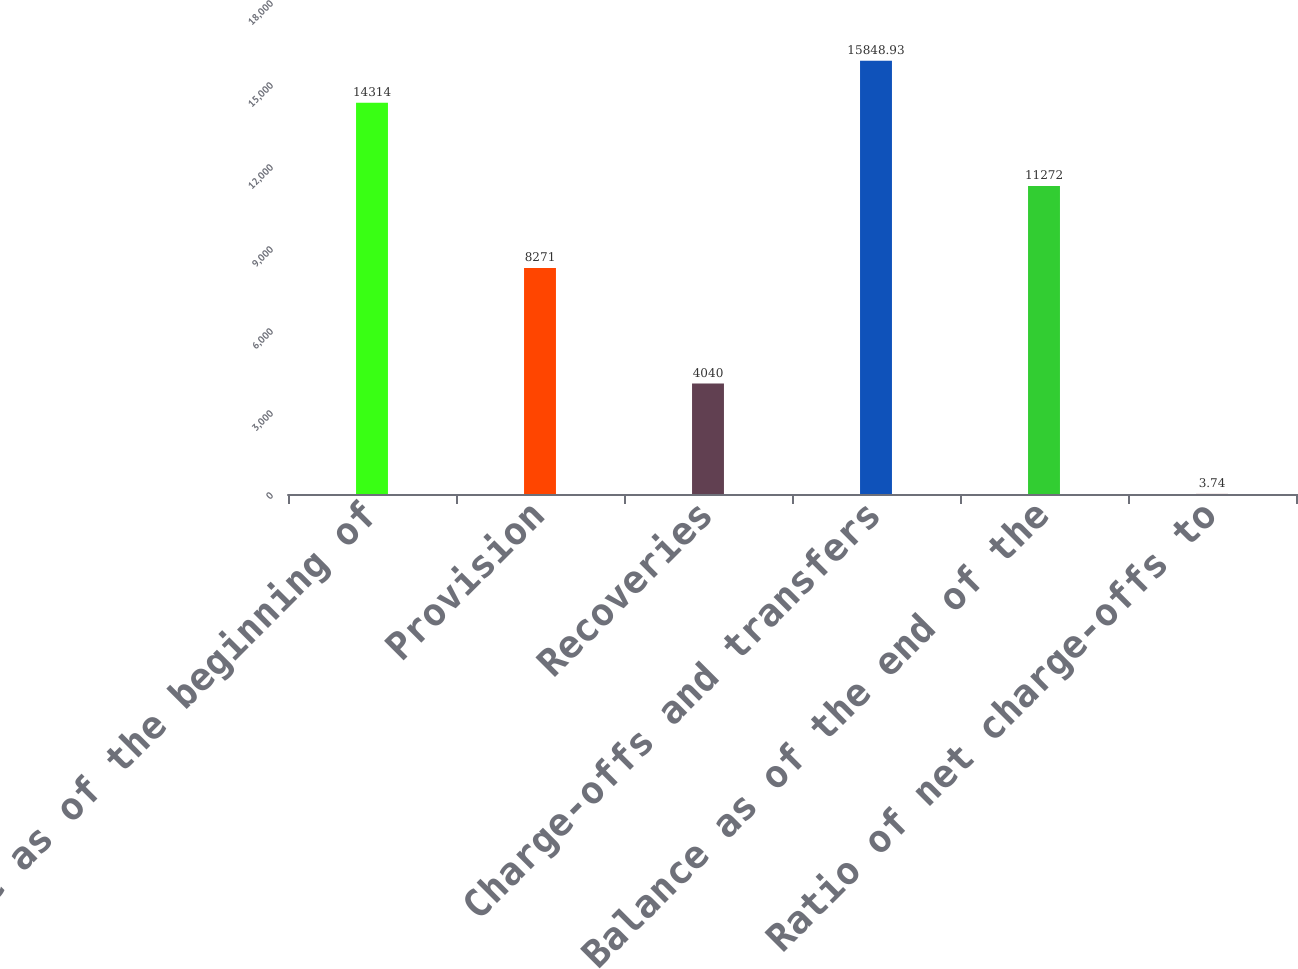Convert chart. <chart><loc_0><loc_0><loc_500><loc_500><bar_chart><fcel>Balance as of the beginning of<fcel>Provision<fcel>Recoveries<fcel>Charge-offs and transfers<fcel>Balance as of the end of the<fcel>Ratio of net charge-offs to<nl><fcel>14314<fcel>8271<fcel>4040<fcel>15848.9<fcel>11272<fcel>3.74<nl></chart> 